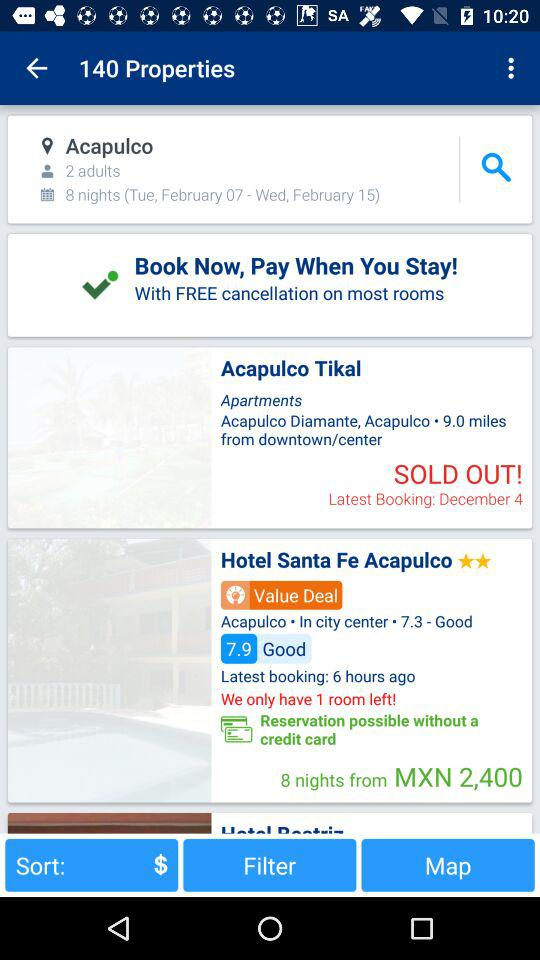What is the address of Acapulco Tikal? The address of Acapulco Tikal is Acapulco Diamante, Acapulco, 9.0 miles from downtown or center. 